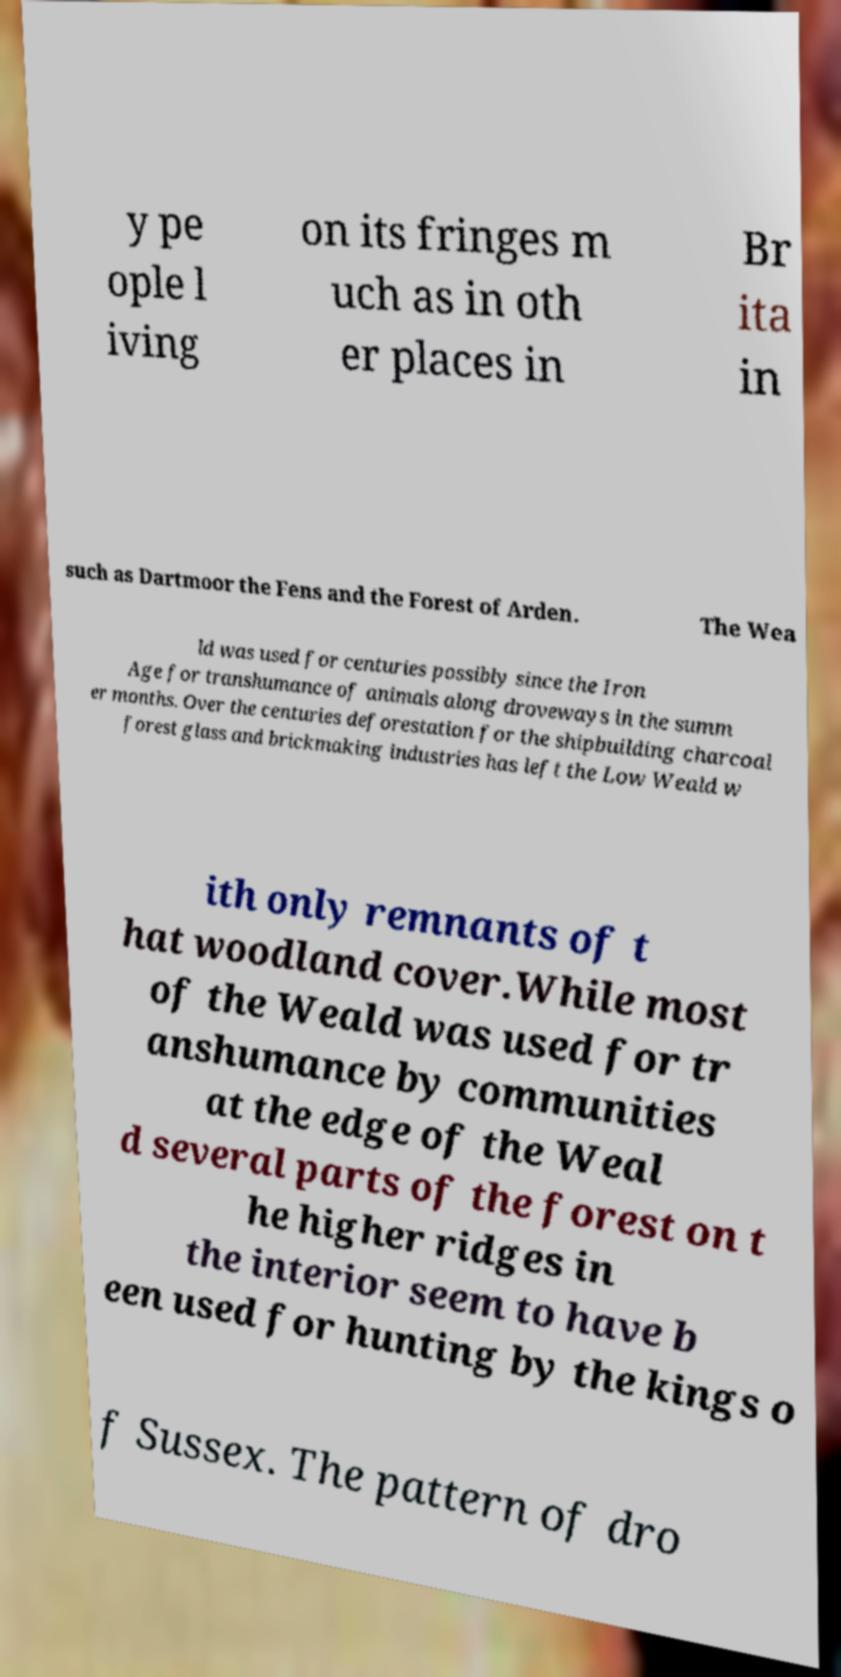Can you read and provide the text displayed in the image?This photo seems to have some interesting text. Can you extract and type it out for me? y pe ople l iving on its fringes m uch as in oth er places in Br ita in such as Dartmoor the Fens and the Forest of Arden. The Wea ld was used for centuries possibly since the Iron Age for transhumance of animals along droveways in the summ er months. Over the centuries deforestation for the shipbuilding charcoal forest glass and brickmaking industries has left the Low Weald w ith only remnants of t hat woodland cover.While most of the Weald was used for tr anshumance by communities at the edge of the Weal d several parts of the forest on t he higher ridges in the interior seem to have b een used for hunting by the kings o f Sussex. The pattern of dro 